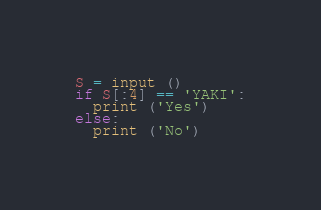<code> <loc_0><loc_0><loc_500><loc_500><_Python_>S = input ()
if S[:4] == 'YAKI':
  print ('Yes')
else:
  print ('No')</code> 